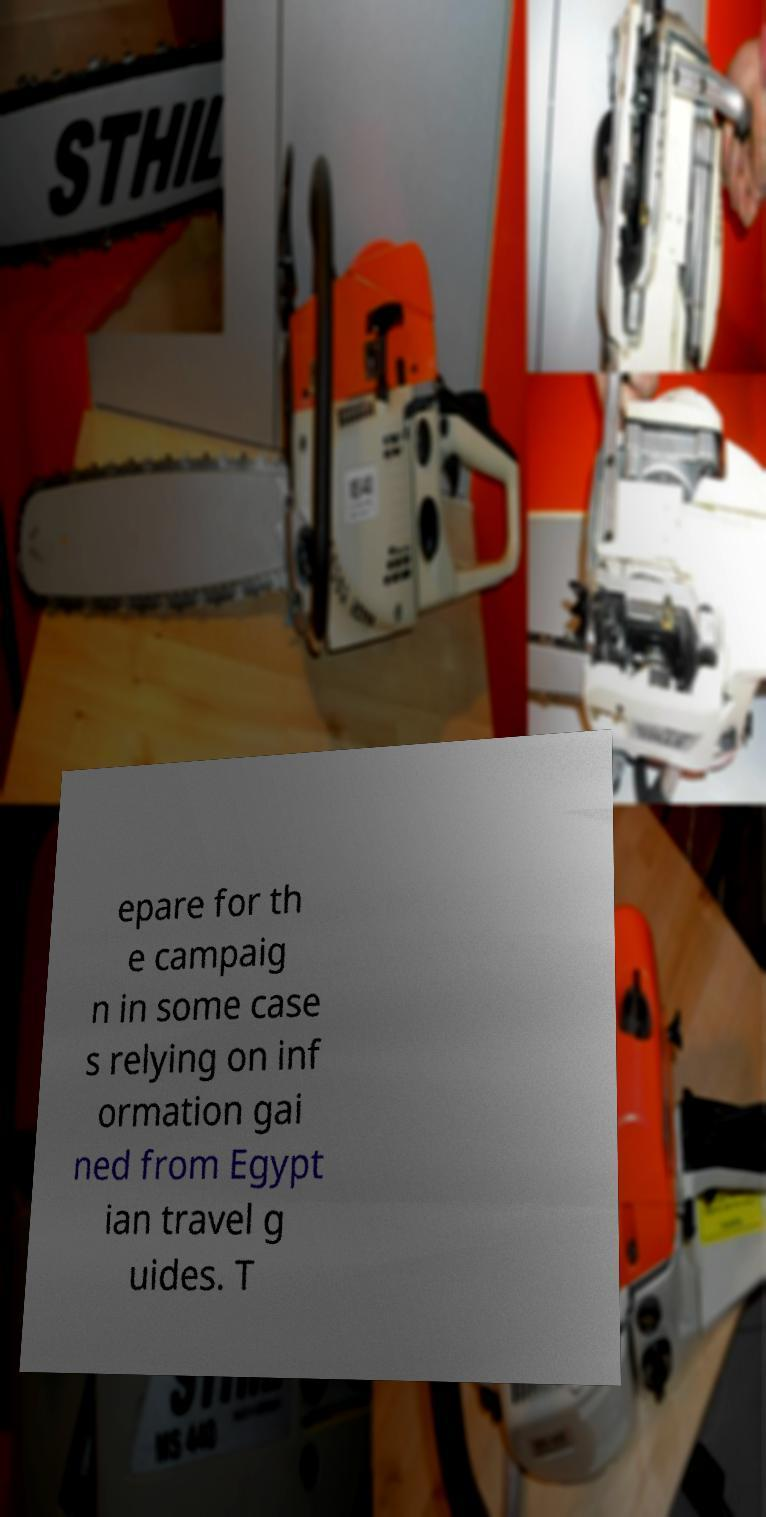I need the written content from this picture converted into text. Can you do that? epare for th e campaig n in some case s relying on inf ormation gai ned from Egypt ian travel g uides. T 